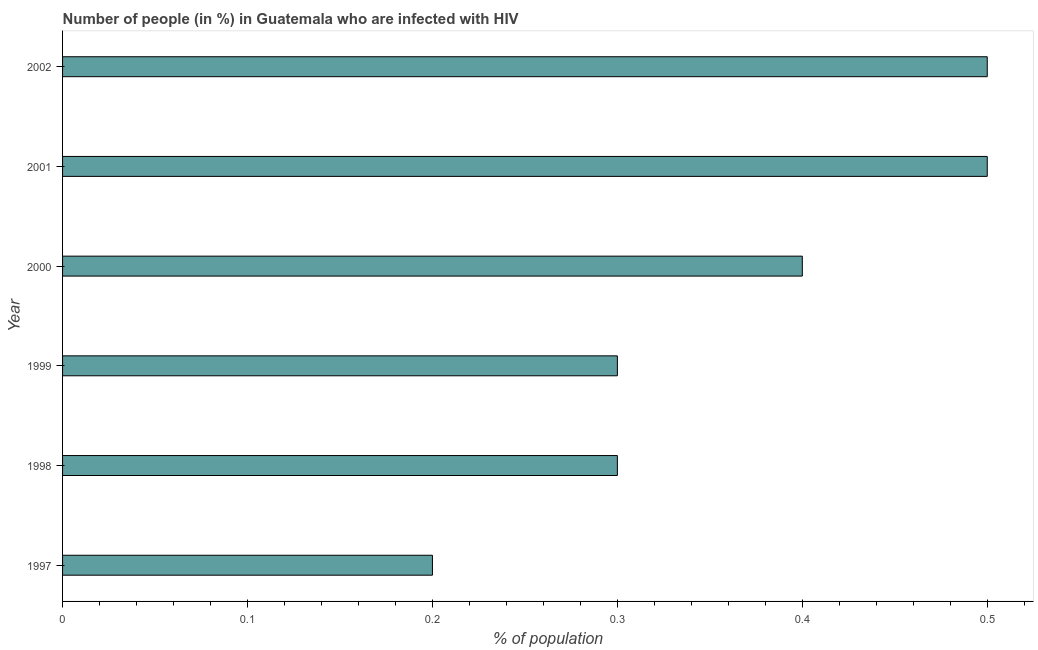Does the graph contain any zero values?
Ensure brevity in your answer.  No. Does the graph contain grids?
Your response must be concise. No. What is the title of the graph?
Provide a short and direct response. Number of people (in %) in Guatemala who are infected with HIV. What is the label or title of the X-axis?
Your answer should be compact. % of population. What is the label or title of the Y-axis?
Provide a succinct answer. Year. What is the number of people infected with hiv in 1997?
Offer a terse response. 0.2. Across all years, what is the maximum number of people infected with hiv?
Offer a very short reply. 0.5. What is the difference between the number of people infected with hiv in 1997 and 1998?
Offer a terse response. -0.1. What is the average number of people infected with hiv per year?
Your answer should be very brief. 0.37. In how many years, is the number of people infected with hiv greater than 0.36 %?
Offer a very short reply. 3. Do a majority of the years between 2000 and 1997 (inclusive) have number of people infected with hiv greater than 0.1 %?
Offer a terse response. Yes. What is the ratio of the number of people infected with hiv in 1999 to that in 2002?
Your response must be concise. 0.6. In how many years, is the number of people infected with hiv greater than the average number of people infected with hiv taken over all years?
Your response must be concise. 3. How many bars are there?
Your answer should be very brief. 6. How many years are there in the graph?
Keep it short and to the point. 6. What is the % of population in 1998?
Keep it short and to the point. 0.3. What is the % of population of 1999?
Your answer should be compact. 0.3. What is the % of population of 2000?
Provide a succinct answer. 0.4. What is the difference between the % of population in 1997 and 1999?
Offer a very short reply. -0.1. What is the difference between the % of population in 1997 and 2000?
Keep it short and to the point. -0.2. What is the difference between the % of population in 1997 and 2002?
Your response must be concise. -0.3. What is the difference between the % of population in 1998 and 2000?
Make the answer very short. -0.1. What is the difference between the % of population in 1998 and 2001?
Make the answer very short. -0.2. What is the difference between the % of population in 1999 and 2001?
Your answer should be very brief. -0.2. What is the difference between the % of population in 1999 and 2002?
Your answer should be compact. -0.2. What is the difference between the % of population in 2000 and 2001?
Ensure brevity in your answer.  -0.1. What is the difference between the % of population in 2001 and 2002?
Your answer should be very brief. 0. What is the ratio of the % of population in 1997 to that in 1998?
Your answer should be compact. 0.67. What is the ratio of the % of population in 1997 to that in 1999?
Your answer should be compact. 0.67. What is the ratio of the % of population in 1997 to that in 2001?
Make the answer very short. 0.4. What is the ratio of the % of population in 1998 to that in 2001?
Ensure brevity in your answer.  0.6. What is the ratio of the % of population in 1999 to that in 2000?
Offer a very short reply. 0.75. What is the ratio of the % of population in 2000 to that in 2001?
Make the answer very short. 0.8. What is the ratio of the % of population in 2001 to that in 2002?
Give a very brief answer. 1. 